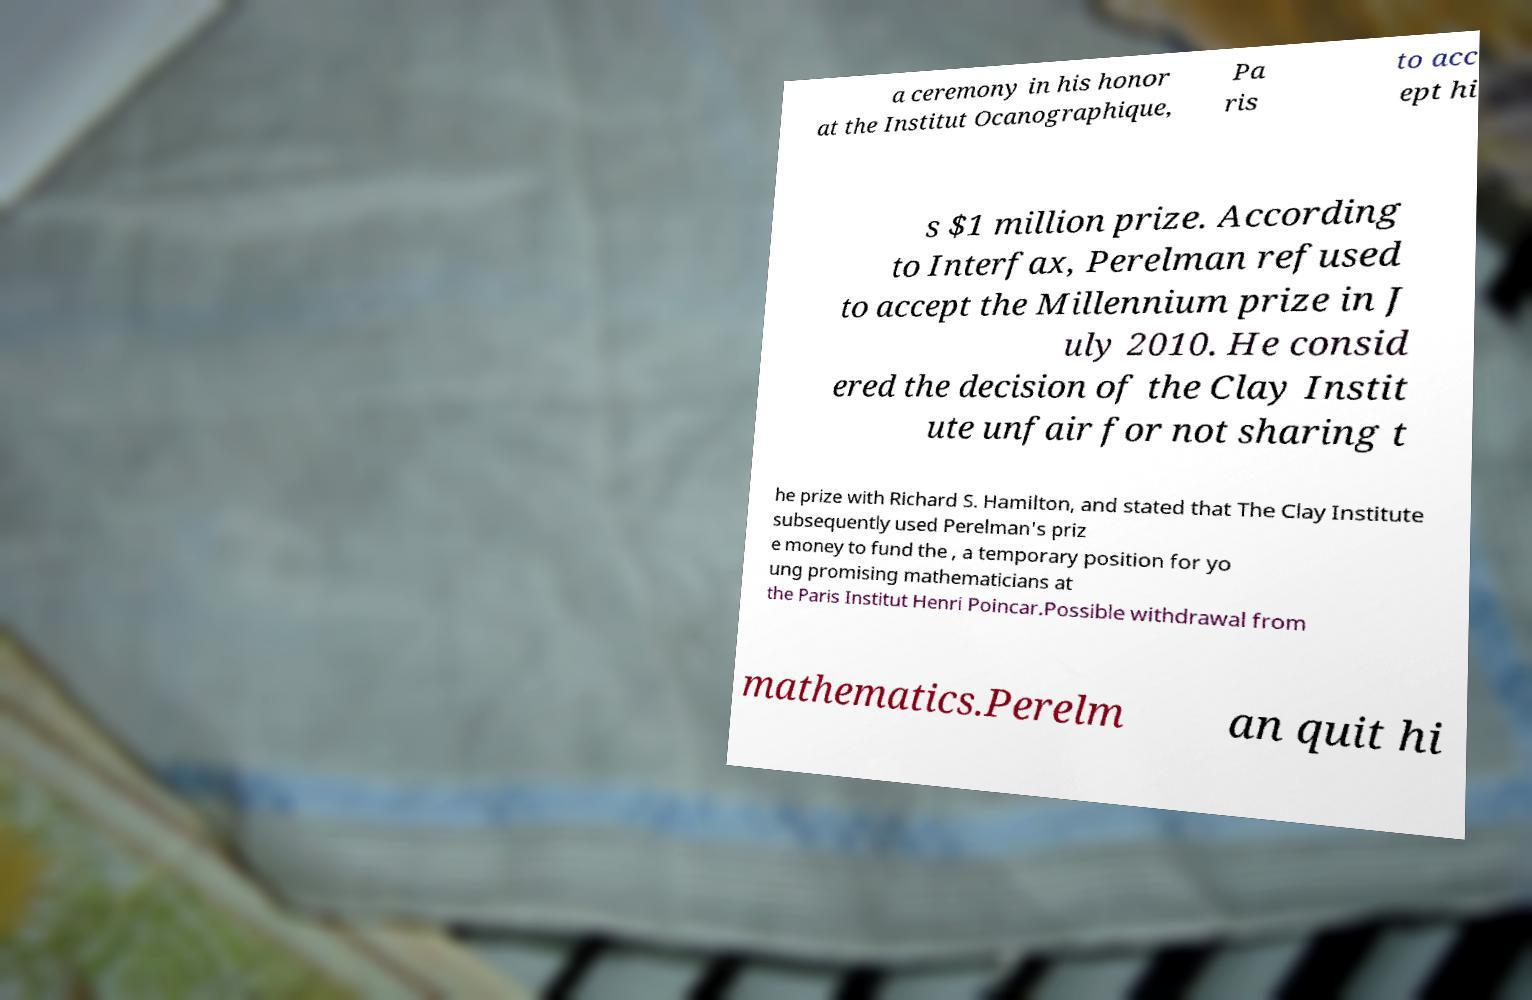Can you read and provide the text displayed in the image?This photo seems to have some interesting text. Can you extract and type it out for me? a ceremony in his honor at the Institut Ocanographique, Pa ris to acc ept hi s $1 million prize. According to Interfax, Perelman refused to accept the Millennium prize in J uly 2010. He consid ered the decision of the Clay Instit ute unfair for not sharing t he prize with Richard S. Hamilton, and stated that The Clay Institute subsequently used Perelman's priz e money to fund the , a temporary position for yo ung promising mathematicians at the Paris Institut Henri Poincar.Possible withdrawal from mathematics.Perelm an quit hi 